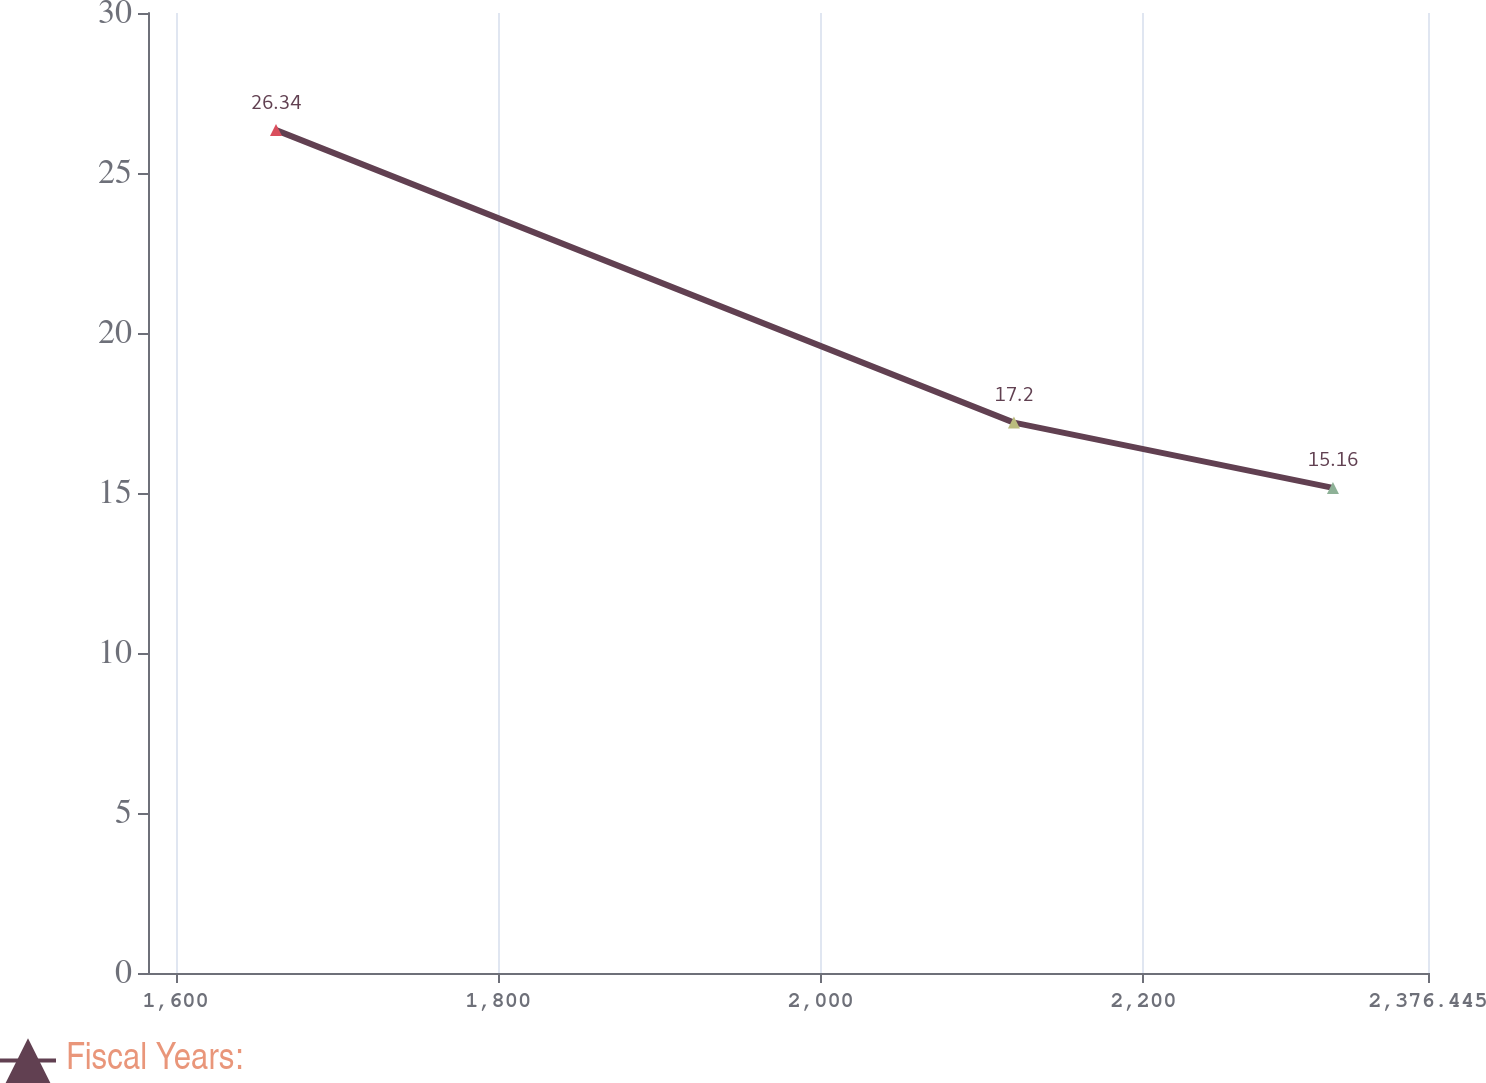Convert chart. <chart><loc_0><loc_0><loc_500><loc_500><line_chart><ecel><fcel>Fiscal Years:<nl><fcel>1662.25<fcel>26.34<nl><fcel>2119.76<fcel>17.2<nl><fcel>2317.5<fcel>15.16<nl><fcel>2386.65<fcel>13.76<nl><fcel>2455.8<fcel>12.36<nl></chart> 